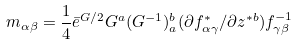<formula> <loc_0><loc_0><loc_500><loc_500>m _ { \alpha \beta } = \frac { 1 } { 4 } \bar { e } ^ { G / 2 } G ^ { a } ( G ^ { - 1 } ) ^ { b } _ { a } ( \partial f ^ { * } _ { \alpha \gamma } / \partial z ^ { * b } ) f ^ { - 1 } _ { \gamma \beta }</formula> 